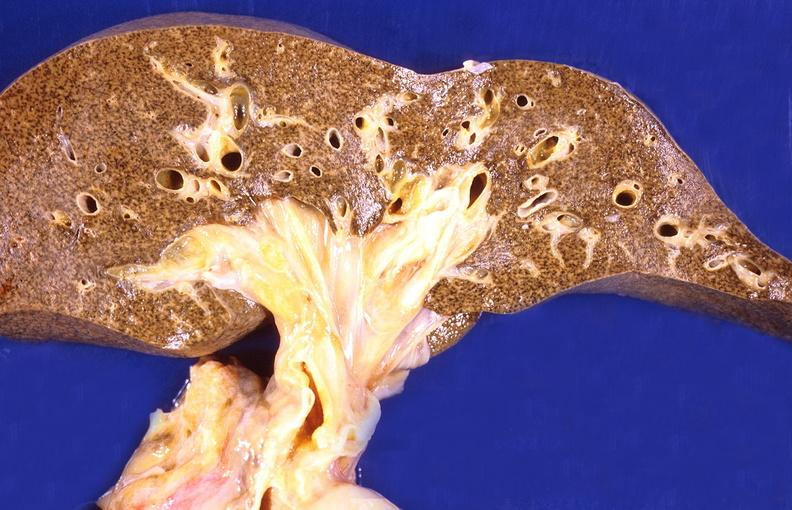s hepatobiliary present?
Answer the question using a single word or phrase. Yes 